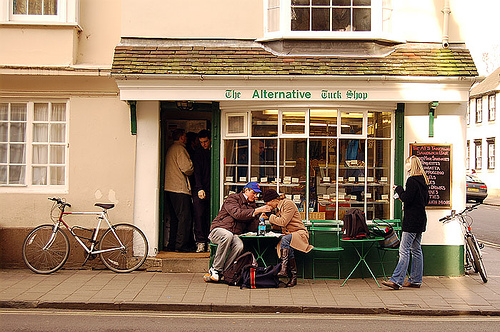<image>
Is there a window above the woman? Yes. The window is positioned above the woman in the vertical space, higher up in the scene. 